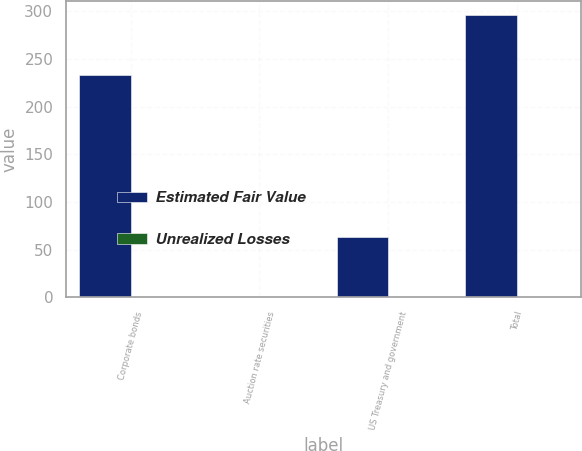<chart> <loc_0><loc_0><loc_500><loc_500><stacked_bar_chart><ecel><fcel>Corporate bonds<fcel>Auction rate securities<fcel>US Treasury and government<fcel>Total<nl><fcel>Estimated Fair Value<fcel>233.1<fcel>0<fcel>63<fcel>296.1<nl><fcel>Unrealized Losses<fcel>0.5<fcel>0<fcel>0.1<fcel>0.6<nl></chart> 